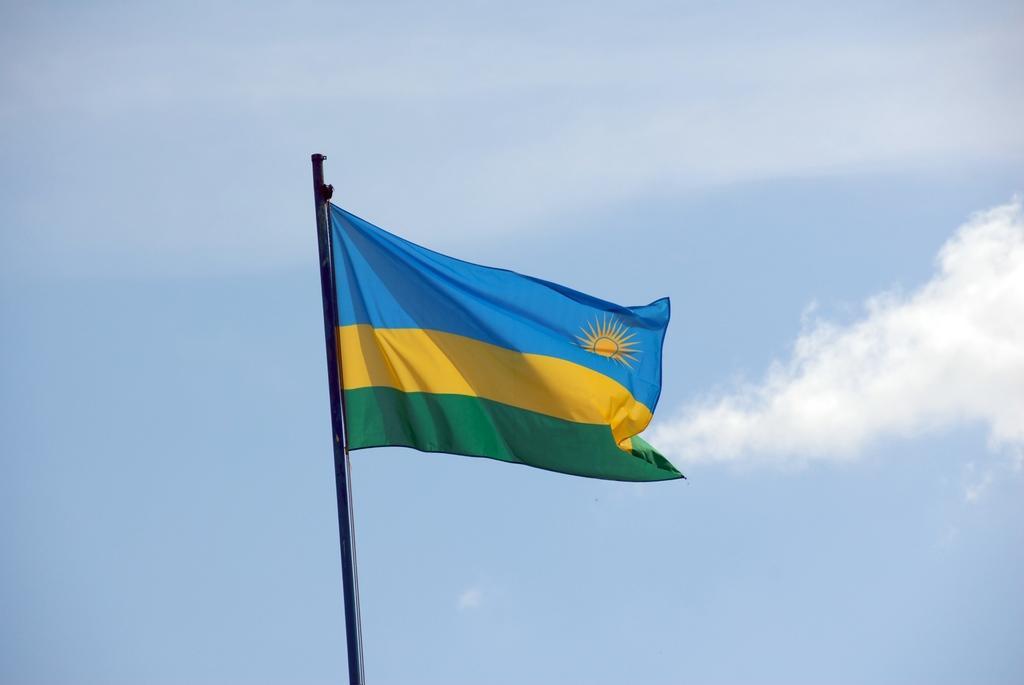Please provide a concise description of this image. In this image I can see a black colored pole to which I can see a flag which is blue, yellow and green in color. In the background I can see the sky. 